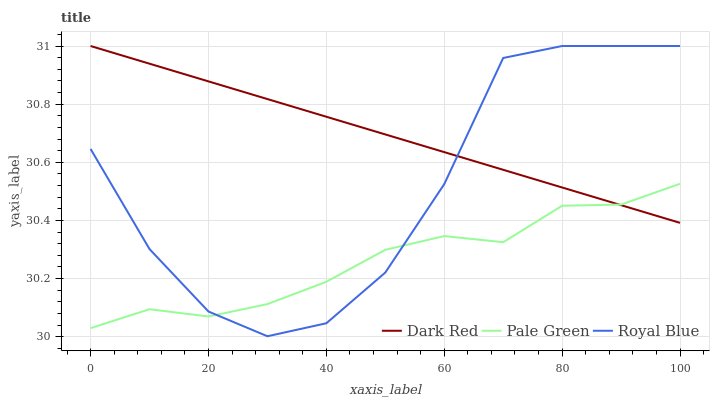Does Pale Green have the minimum area under the curve?
Answer yes or no. Yes. Does Dark Red have the maximum area under the curve?
Answer yes or no. Yes. Does Royal Blue have the minimum area under the curve?
Answer yes or no. No. Does Royal Blue have the maximum area under the curve?
Answer yes or no. No. Is Dark Red the smoothest?
Answer yes or no. Yes. Is Royal Blue the roughest?
Answer yes or no. Yes. Is Pale Green the smoothest?
Answer yes or no. No. Is Pale Green the roughest?
Answer yes or no. No. Does Royal Blue have the lowest value?
Answer yes or no. Yes. Does Pale Green have the lowest value?
Answer yes or no. No. Does Royal Blue have the highest value?
Answer yes or no. Yes. Does Pale Green have the highest value?
Answer yes or no. No. Does Pale Green intersect Dark Red?
Answer yes or no. Yes. Is Pale Green less than Dark Red?
Answer yes or no. No. Is Pale Green greater than Dark Red?
Answer yes or no. No. 